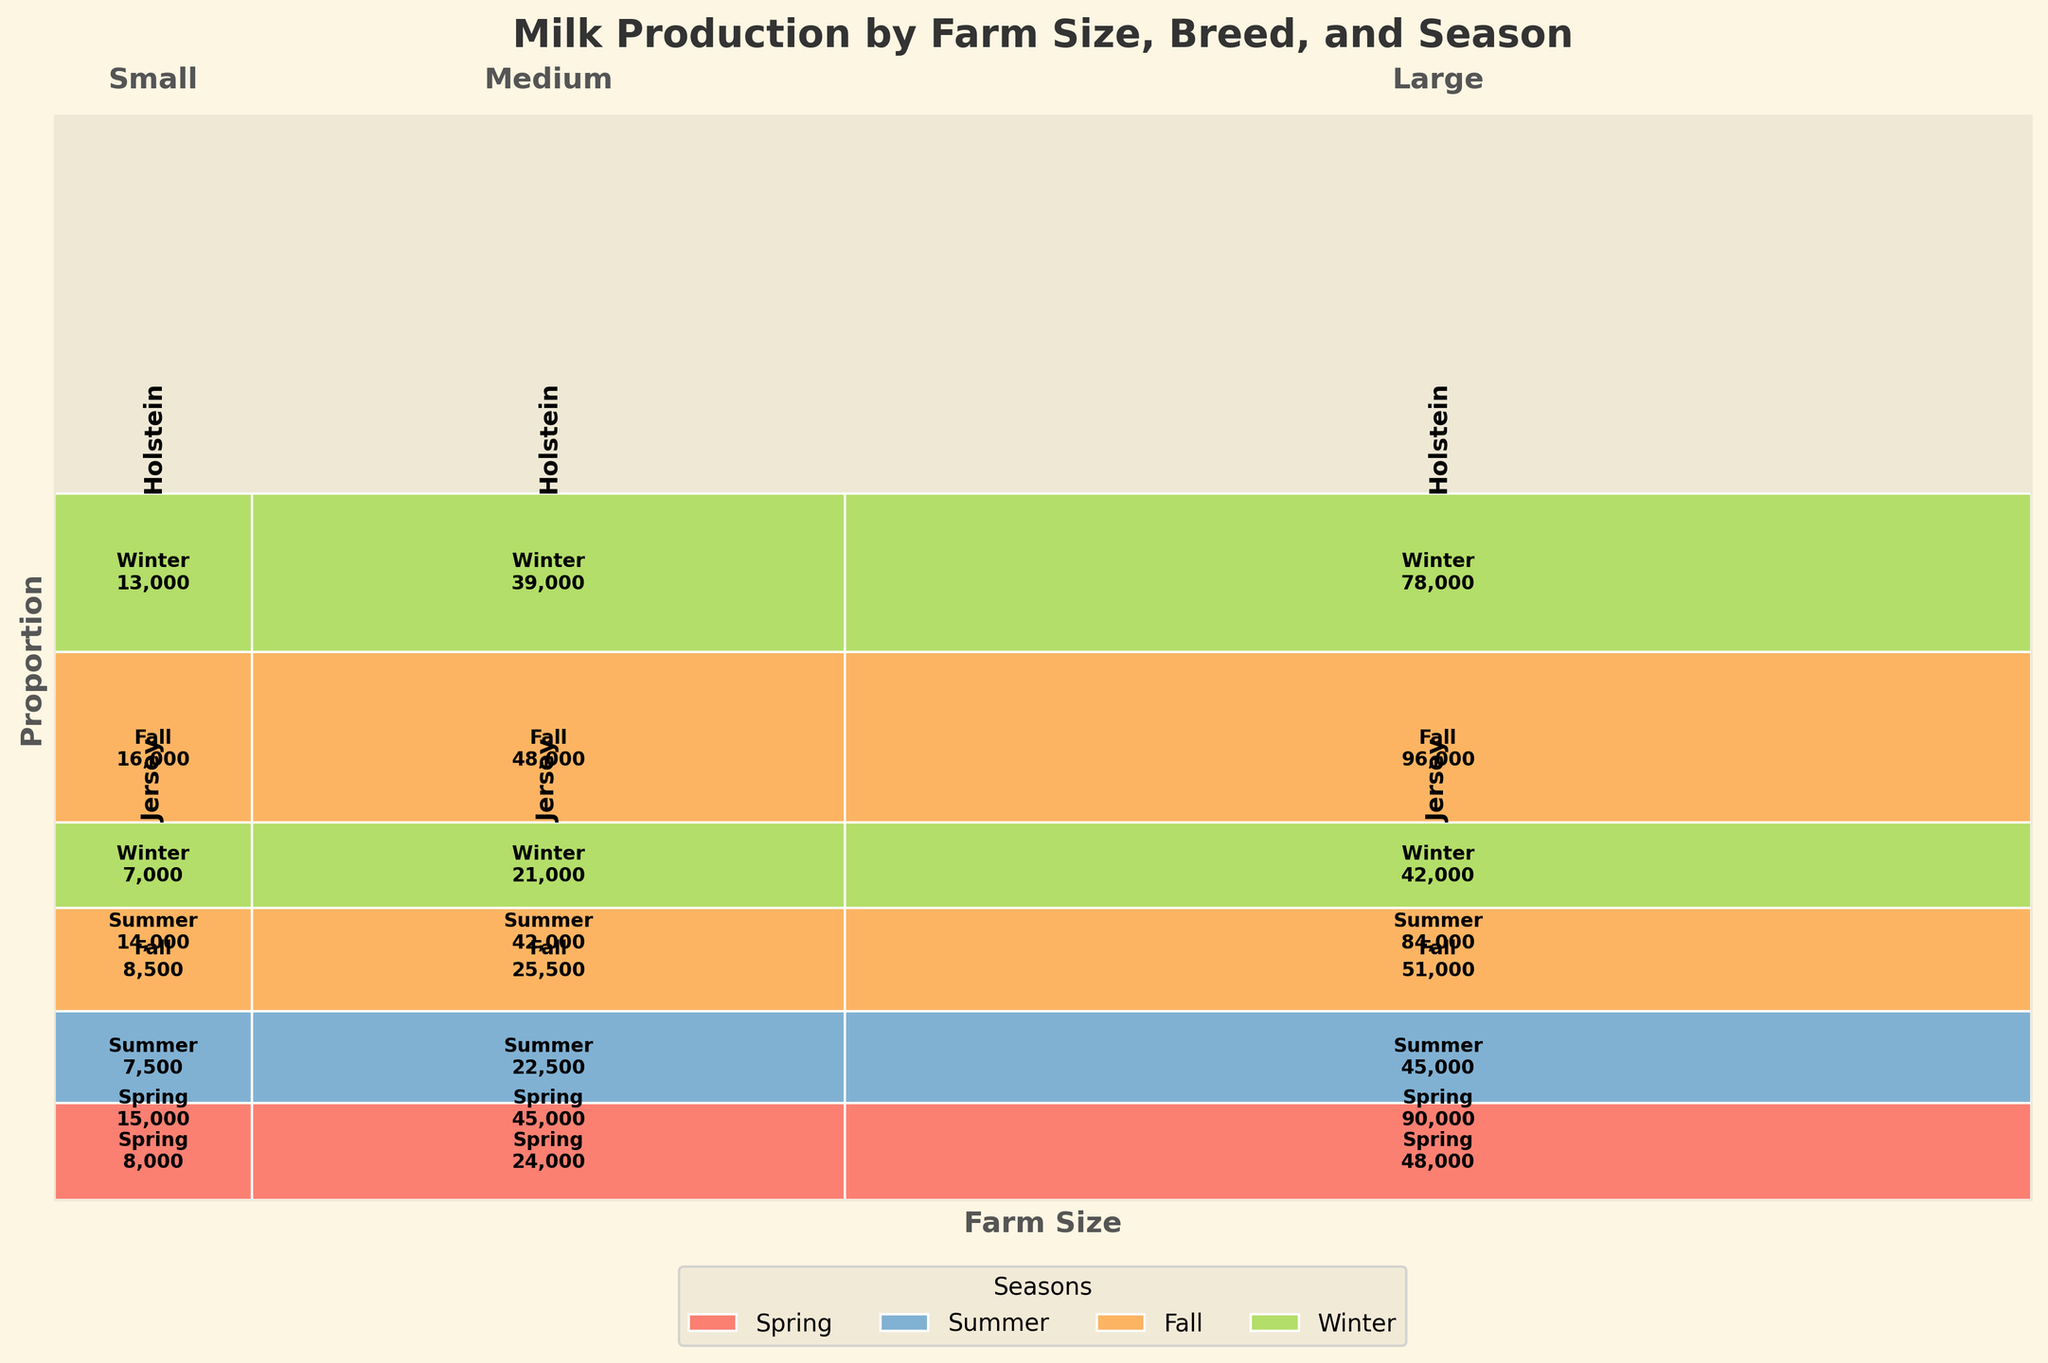What is the title of the plot? The title of the plot is usually located at the top center of the figure. It provides an overview of the content displayed in the figure. In this case, the title is "Milk Production by Farm Size, Breed, and Season".
Answer: Milk Production by Farm Size, Breed, and Season Which breed produces more milk during the Summer season across all farm sizes? To answer this, you'll need to compare the total milk production in the Summer season for both Holstein and Jersey breeds across different farm sizes (Small, Medium, Large). The production values for Holstein in Summer are: 14000 + 42000 + 84000 = 140000 gallons. For Jersey in Summer: 7500 + 22500 + 45000 = 75000 gallons. Holstein produces more.
Answer: Holstein How does the milk production in Fall compare between Medium and Large farms for the Jersey breed? First, identify the milk production in Fall for Jersey breed on Medium farms (25500 gallons) and Large farms (51000 gallons). Comparing these two values, it is evident that Large farms produce more milk than Medium farms in the Fall season.
Answer: Large farms produce more What proportion of total milk production comes from Holstein cows on Large farms in the Spring? Calculate the total milk production from the entire dataset. Total production = 15000 + 14000 + ... + 42000 = 669000 gallons. Then find the Spring production for Holstein on Large farms: 90000 gallons. Divide: 90000/669000 = approx 0.1345 or 13.45%.
Answer: 13.45% In which season do Small farms produce the least milk for Holstein cows, and what is the amount? To find this, look at the production data for all seasons for Holstein cows on Small farms. Spring: 15000, Summer: 14000, Fall: 16000, Winter: 13000. The least production is in Winter, with 13000 gallons.
Answer: Winter, 13000 gallons Which farm size contributes most to the Winter milk production for Holstein cows? Compare the Winter production across different farm sizes for Holstein cows. Small: 13000, Medium: 39000, Large: 78000. Large farms contribute the most with 78000 gallons.
Answer: Large farms Is the production for Jersey cows in the Spring season higher or lower on Medium farms compared to Small farms? Compare the Spring production for Jersey cows on Medium farms (24000 gallons) with Small farms (8000 gallons). The production is higher on Medium farms.
Answer: Higher on Medium farms What is the overall trend in milk production for Jersey cows across the four seasons on Small farms? Look at the season-wise production for Jersey cows on Small farms: Spring: 8000, Summer: 7500, Fall: 8500, Winter: 7000. The trend shows: Spring to Summer decreases, Summer to Fall increases, and Fall to Winter decreases.
Answer: Decrease, Increase, Decrease How does milk production by Holstein cows on Medium farms in Summer compare to their production in the Spring? Compare the Holstein production values for Medium farms in Summer (42000 gallons) and Spring (45000 gallons). The Summer production is slightly less than the Spring production.
Answer: Less in Summer What is the largest difference in seasonal milk production for Jersey cows across any farm size? To find the largest difference, compare the seasonal production differences for Jersey cows for each farm size. Analyzing each we get the differences: Small: 8000 - 7000 = 1000, Medium: 24000 - 21000 = 3000, Large: 48000 - 42000 = 6000. The largest difference is 6000 gallons for Large farms.
Answer: 6000 gallons on Large farms 